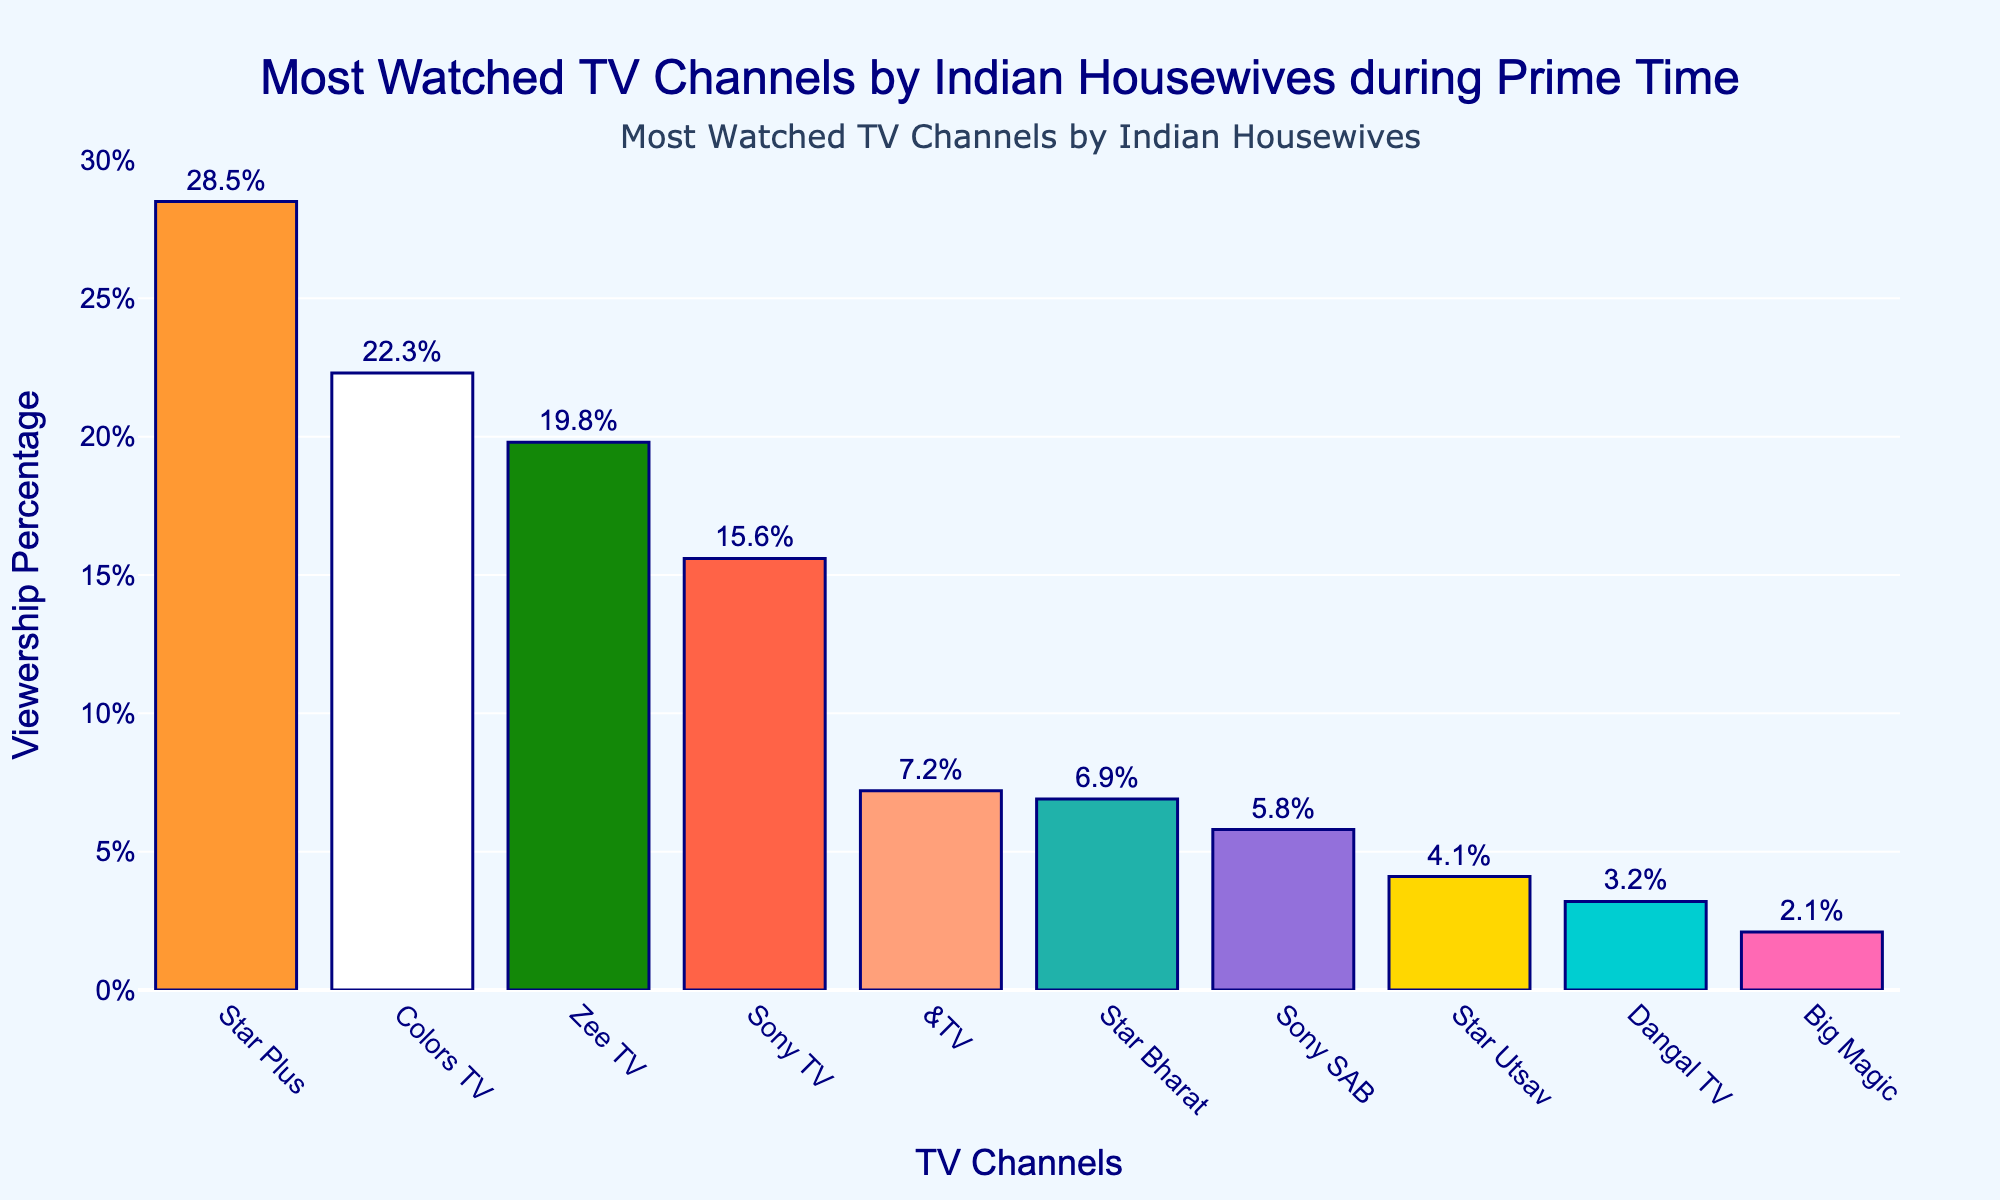Which TV channel has the highest viewership percentage? The bar for Star Plus is the tallest in the figure, indicating it has the highest viewership percentage.
Answer: Star Plus Which channel is watched less, Star Bharat or Sony SAB? Comparing the heights of the bars, the bar for Sony SAB is shorter than the bar for Star Bharat.
Answer: Sony SAB What is the combined viewership percentage of Colors TV and Zee TV? Sum the percentages of Colors TV (22.3%) and Zee TV (19.8%): 22.3 + 19.8 = 42.1%.
Answer: 42.1% How much higher is the viewership of Star Plus compared to &TV? Subtract the percentage of &TV (7.2%) from Star Plus (28.5%): 28.5 - 7.2 = 21.3%.
Answer: 21.3% What is the average viewership percentage of the top three channels? Add the percentages of the top three channels (Star Plus: 28.5%, Colors TV: 22.3%, Zee TV: 19.8%) and divide by 3: (28.5 + 22.3 + 19.8) / 3 = 70.6 / 3 = 23.53%.
Answer: 23.53% Which channel has a viewership percentage closest to 7%? The bar for Star Bharat shows a percentage of 6.9, which is closest to 7%.
Answer: Star Bharat What percentage difference is there between the viewership of Star Bharat and Big Magic? Subtract the viewership percentage of Big Magic (2.1%) from Star Bharat (6.9%): 6.9 - 2.1 = 4.8%.
Answer: 4.8% Rank the channels from highest to lowest viewership percentage. From the tallest to the shortest bar in the figure: Star Plus (28.5%), Colors TV (22.3%), Zee TV (19.8%), Sony TV (15.6%), &TV (7.2%), Star Bharat (6.9%), Sony SAB (5.8%), Star Utsav (4.1%), Dangal TV (3.2%), Big Magic (2.1%).
Answer: Star Plus > Colors TV > Zee TV > Sony TV > &TV > Star Bharat > Sony SAB > Star Utsav > Dangal TV > Big Magic Which channels have a viewership percentage higher than 15%? The channels with bars taller than the 15% mark are Star Plus (28.5%), Colors TV (22.3%), Zee TV (19.8%), and Sony TV (15.6%).
Answer: Star Plus, Colors TV, Zee TV, Sony TV 